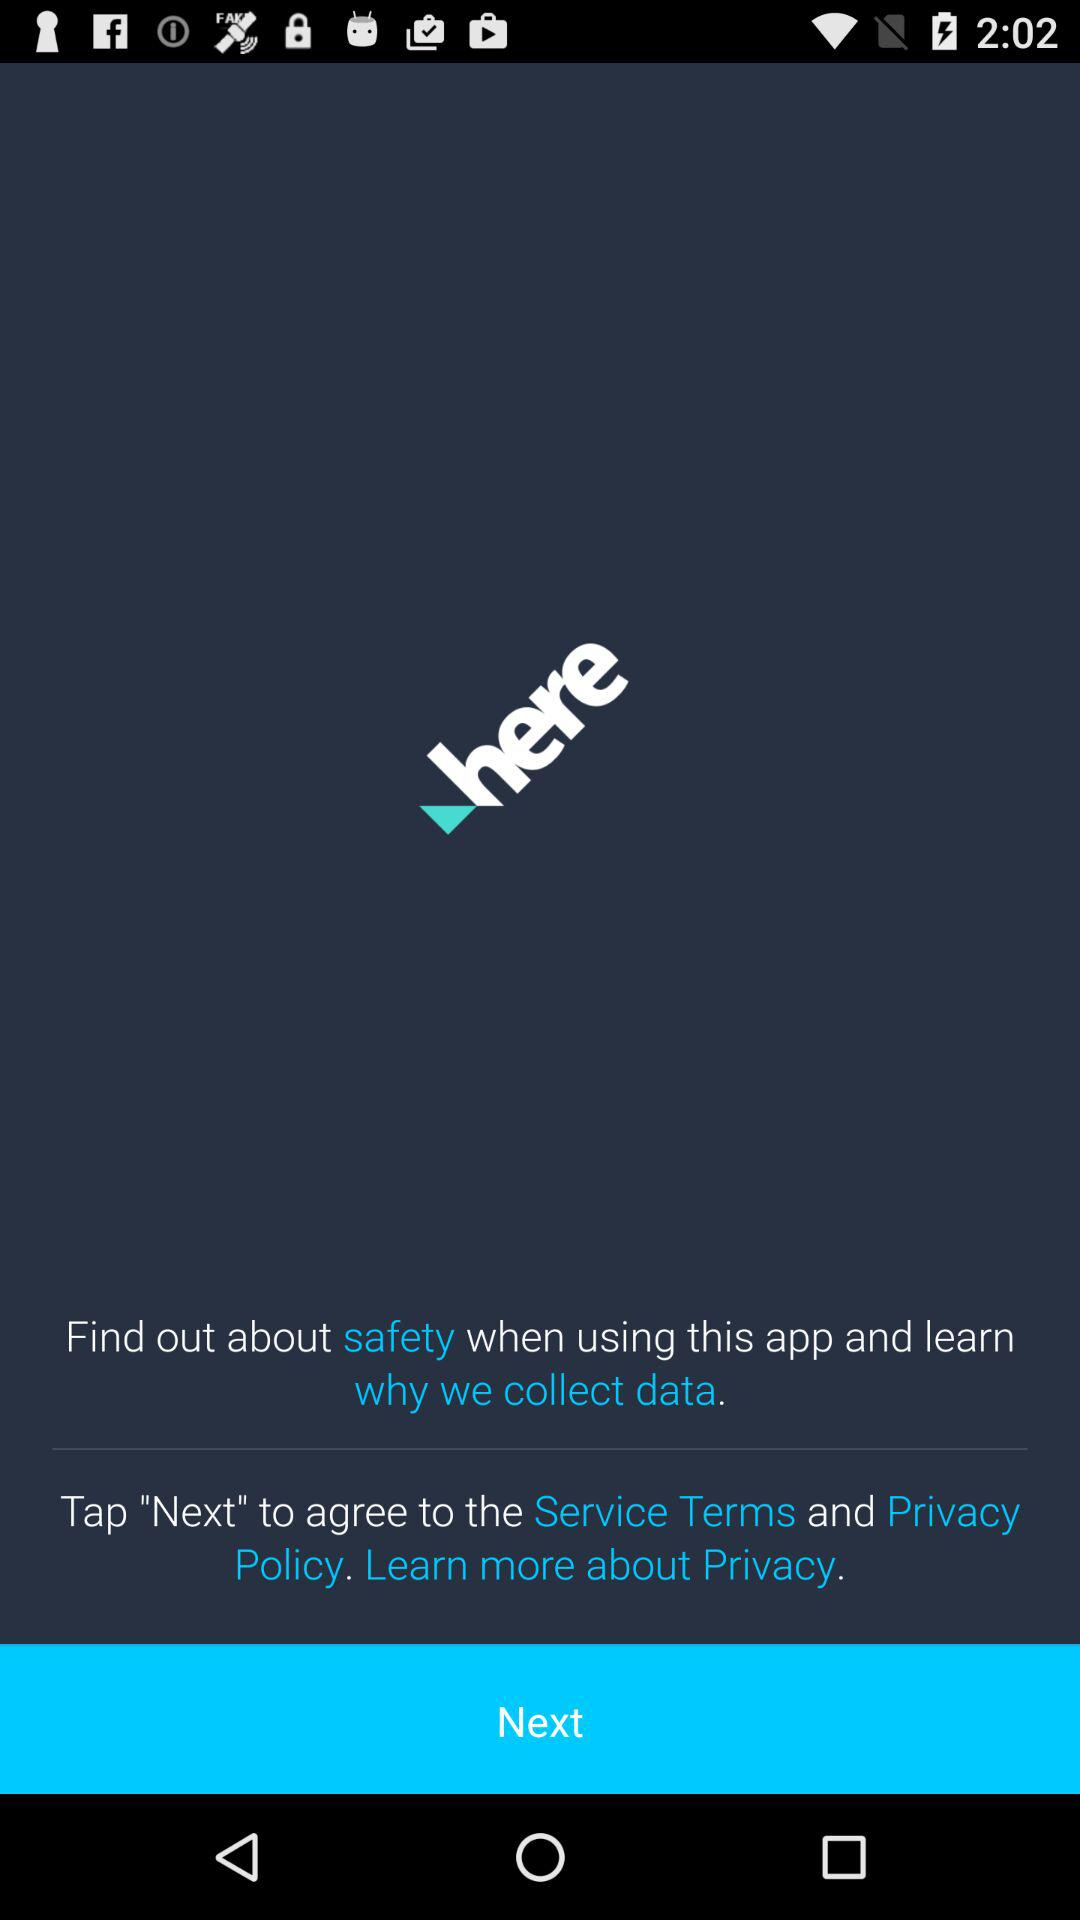What is the application name? The application name is "HERE WeGo: Maps & Navigation". 